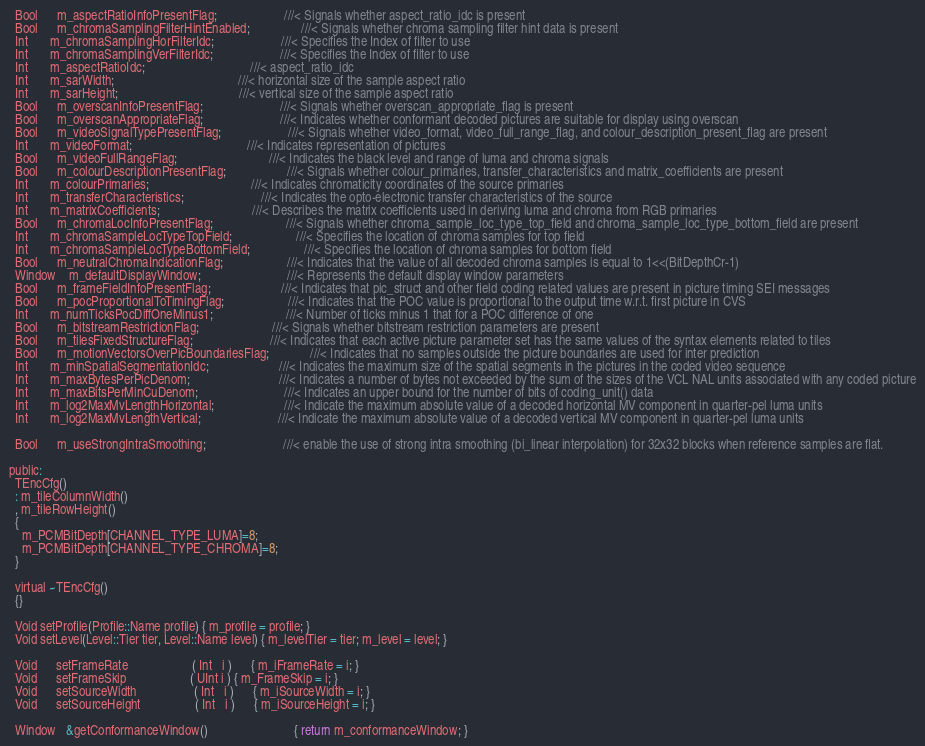<code> <loc_0><loc_0><loc_500><loc_500><_C_>  Bool      m_aspectRatioInfoPresentFlag;                     ///< Signals whether aspect_ratio_idc is present
  Bool      m_chromaSamplingFilterHintEnabled;                ///< Signals whether chroma sampling filter hint data is present
  Int       m_chromaSamplingHorFilterIdc;                     ///< Specifies the Index of filter to use
  Int       m_chromaSamplingVerFilterIdc;                     ///< Specifies the Index of filter to use
  Int       m_aspectRatioIdc;                                 ///< aspect_ratio_idc
  Int       m_sarWidth;                                       ///< horizontal size of the sample aspect ratio
  Int       m_sarHeight;                                      ///< vertical size of the sample aspect ratio
  Bool      m_overscanInfoPresentFlag;                        ///< Signals whether overscan_appropriate_flag is present
  Bool      m_overscanAppropriateFlag;                        ///< Indicates whether conformant decoded pictures are suitable for display using overscan
  Bool      m_videoSignalTypePresentFlag;                     ///< Signals whether video_format, video_full_range_flag, and colour_description_present_flag are present
  Int       m_videoFormat;                                    ///< Indicates representation of pictures
  Bool      m_videoFullRangeFlag;                             ///< Indicates the black level and range of luma and chroma signals
  Bool      m_colourDescriptionPresentFlag;                   ///< Signals whether colour_primaries, transfer_characteristics and matrix_coefficients are present
  Int       m_colourPrimaries;                                ///< Indicates chromaticity coordinates of the source primaries
  Int       m_transferCharacteristics;                        ///< Indicates the opto-electronic transfer characteristics of the source
  Int       m_matrixCoefficients;                             ///< Describes the matrix coefficients used in deriving luma and chroma from RGB primaries
  Bool      m_chromaLocInfoPresentFlag;                       ///< Signals whether chroma_sample_loc_type_top_field and chroma_sample_loc_type_bottom_field are present
  Int       m_chromaSampleLocTypeTopField;                    ///< Specifies the location of chroma samples for top field
  Int       m_chromaSampleLocTypeBottomField;                 ///< Specifies the location of chroma samples for bottom field
  Bool      m_neutralChromaIndicationFlag;                    ///< Indicates that the value of all decoded chroma samples is equal to 1<<(BitDepthCr-1)
  Window    m_defaultDisplayWindow;                           ///< Represents the default display window parameters
  Bool      m_frameFieldInfoPresentFlag;                      ///< Indicates that pic_struct and other field coding related values are present in picture timing SEI messages
  Bool      m_pocProportionalToTimingFlag;                    ///< Indicates that the POC value is proportional to the output time w.r.t. first picture in CVS
  Int       m_numTicksPocDiffOneMinus1;                       ///< Number of ticks minus 1 that for a POC difference of one
  Bool      m_bitstreamRestrictionFlag;                       ///< Signals whether bitstream restriction parameters are present
  Bool      m_tilesFixedStructureFlag;                        ///< Indicates that each active picture parameter set has the same values of the syntax elements related to tiles
  Bool      m_motionVectorsOverPicBoundariesFlag;             ///< Indicates that no samples outside the picture boundaries are used for inter prediction
  Int       m_minSpatialSegmentationIdc;                      ///< Indicates the maximum size of the spatial segments in the pictures in the coded video sequence
  Int       m_maxBytesPerPicDenom;                            ///< Indicates a number of bytes not exceeded by the sum of the sizes of the VCL NAL units associated with any coded picture
  Int       m_maxBitsPerMinCuDenom;                           ///< Indicates an upper bound for the number of bits of coding_unit() data
  Int       m_log2MaxMvLengthHorizontal;                      ///< Indicate the maximum absolute value of a decoded horizontal MV component in quarter-pel luma units
  Int       m_log2MaxMvLengthVertical;                        ///< Indicate the maximum absolute value of a decoded vertical MV component in quarter-pel luma units

  Bool      m_useStrongIntraSmoothing;                        ///< enable the use of strong intra smoothing (bi_linear interpolation) for 32x32 blocks when reference samples are flat.

public:
  TEncCfg()
  : m_tileColumnWidth()
  , m_tileRowHeight()
  {
    m_PCMBitDepth[CHANNEL_TYPE_LUMA]=8;
    m_PCMBitDepth[CHANNEL_TYPE_CHROMA]=8;
  }

  virtual ~TEncCfg()
  {}

  Void setProfile(Profile::Name profile) { m_profile = profile; }
  Void setLevel(Level::Tier tier, Level::Name level) { m_levelTier = tier; m_level = level; }

  Void      setFrameRate                    ( Int   i )      { m_iFrameRate = i; }
  Void      setFrameSkip                    ( UInt i ) { m_FrameSkip = i; }
  Void      setSourceWidth                  ( Int   i )      { m_iSourceWidth = i; }
  Void      setSourceHeight                 ( Int   i )      { m_iSourceHeight = i; }

  Window   &getConformanceWindow()                           { return m_conformanceWindow; }</code> 